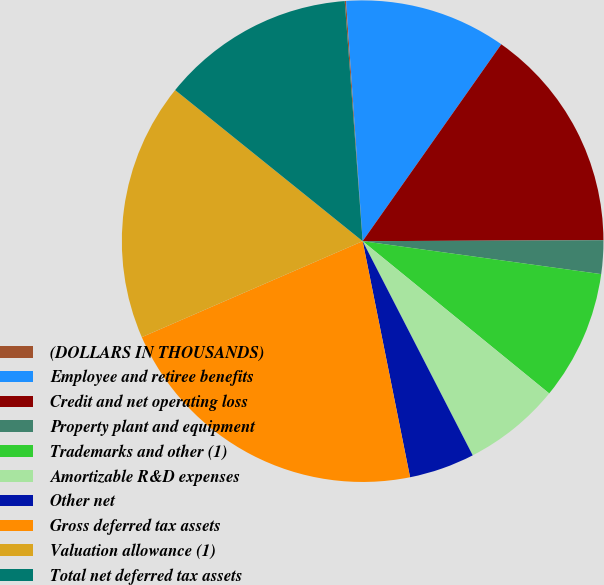Convert chart. <chart><loc_0><loc_0><loc_500><loc_500><pie_chart><fcel>(DOLLARS IN THOUSANDS)<fcel>Employee and retiree benefits<fcel>Credit and net operating loss<fcel>Property plant and equipment<fcel>Trademarks and other (1)<fcel>Amortizable R&D expenses<fcel>Other net<fcel>Gross deferred tax assets<fcel>Valuation allowance (1)<fcel>Total net deferred tax assets<nl><fcel>0.09%<fcel>10.86%<fcel>15.17%<fcel>2.25%<fcel>8.71%<fcel>6.55%<fcel>4.4%<fcel>21.63%<fcel>17.32%<fcel>13.02%<nl></chart> 